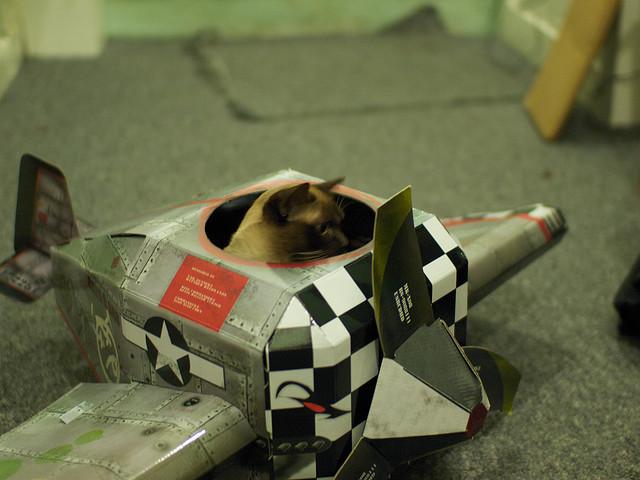What material is on the ground in this image?
Be succinct. Carpet. What kind of weird object is this?
Concise answer only. Plane. Who is flying this contraption?
Concise answer only. Cat. 